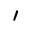<formula> <loc_0><loc_0><loc_500><loc_500>^ { \prime }</formula> 